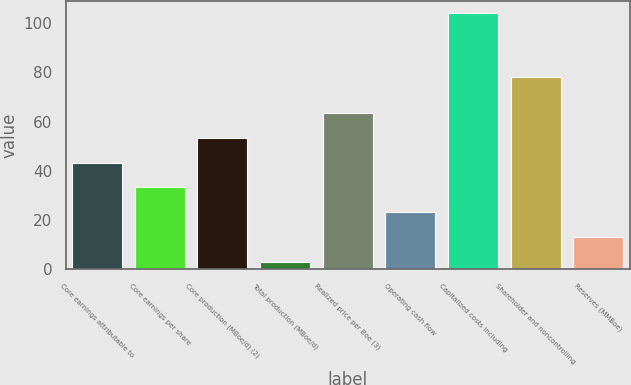<chart> <loc_0><loc_0><loc_500><loc_500><bar_chart><fcel>Core earnings attributable to<fcel>Core earnings per share<fcel>Core production (MBoe/d) (2)<fcel>Total production (MBoe/d)<fcel>Realized price per Boe (3)<fcel>Operating cash flow<fcel>Capitalized costs including<fcel>Shareholder and noncontrolling<fcel>Reserves (MMBoe)<nl><fcel>43.4<fcel>33.3<fcel>53.5<fcel>3<fcel>63.6<fcel>23.2<fcel>104<fcel>78<fcel>13.1<nl></chart> 